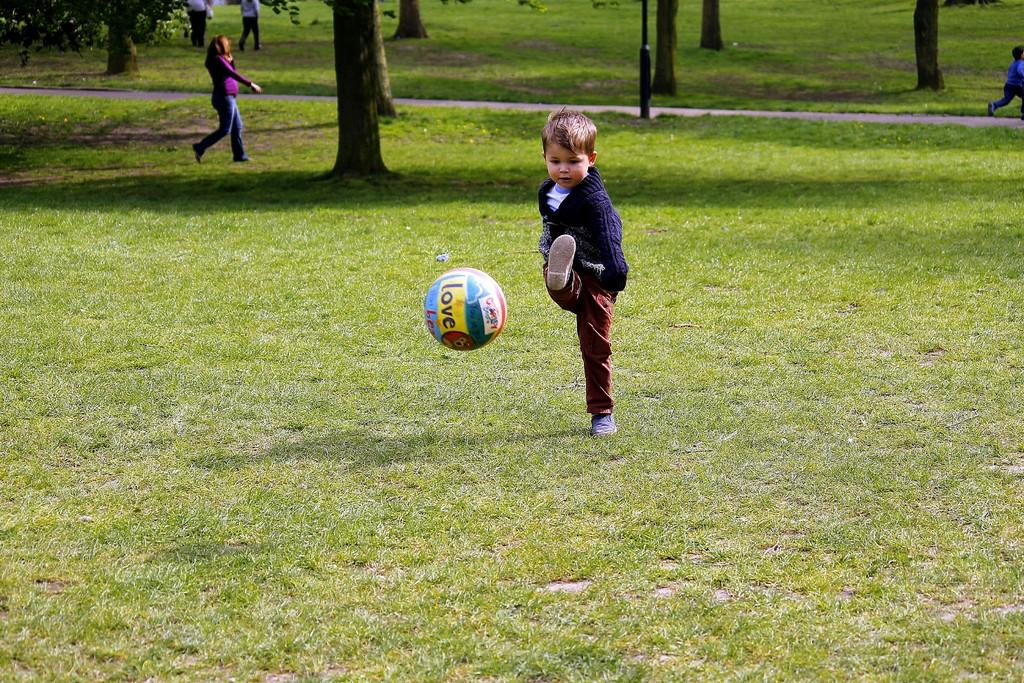What is the boy in the image attempting to do? The boy is trying to hit a ball in the image. What are the people in the image doing? People are walking in the image are walking in the grass. What type of vegetation can be seen in the image? There are trees in the image. What type of chess piece is the boy using to hit the ball in the image? There is no chess piece present in the image; the boy is using a bat or similar object to hit the ball. 